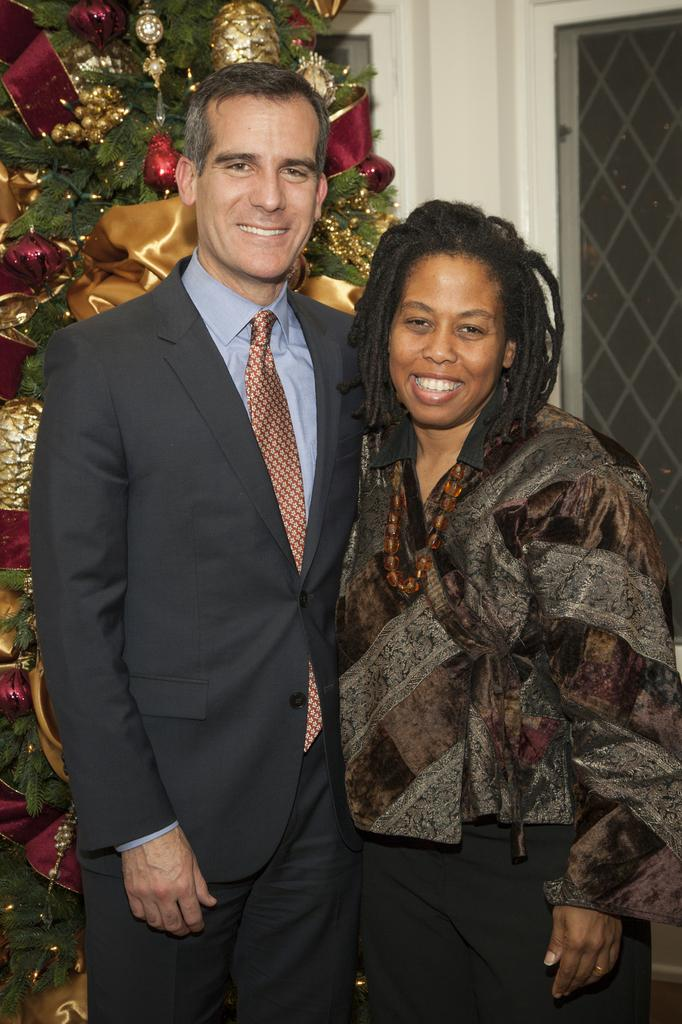Who is present in the image? There is a man and a woman in the image. What are the expressions on their faces? Both the man and the woman are smiling. What can be seen in the background of the image? There is a tree and decoration things in the background of the image. What type of creature is causing the smoke in the image? There is no smoke present in the image, and therefore no creature causing it. What is the yoke used for in the image? There is no yoke present in the image. 